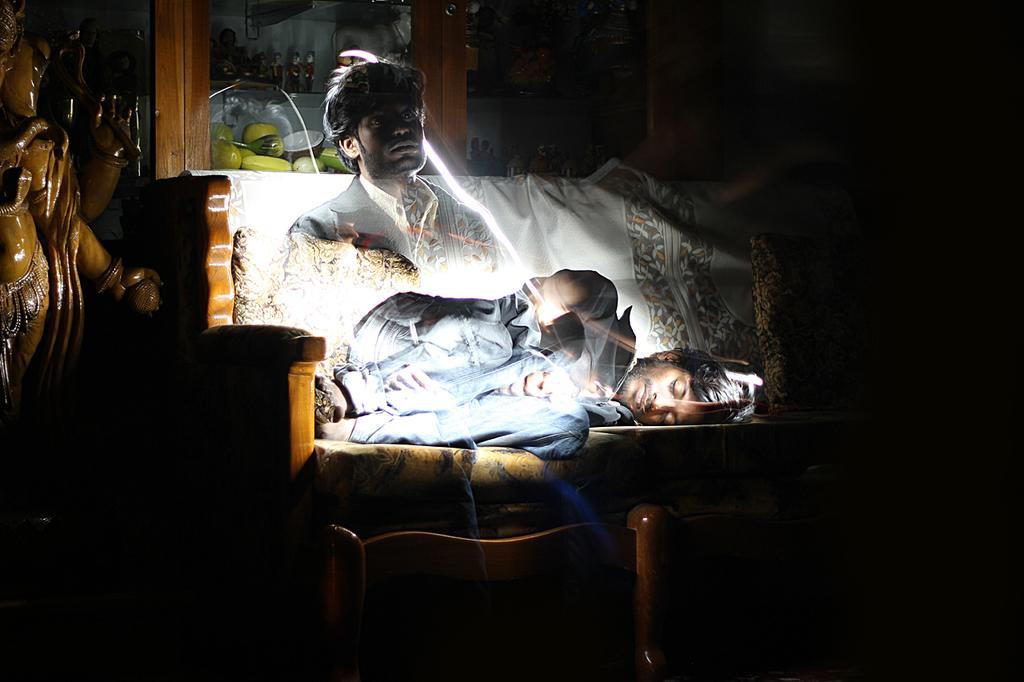Describe this image in one or two sentences. In the image on the sofa there's a man lying on it. And there is another man in transparent. On the left side of the image there is a statue. In the background there is a glass cupboard with few items in it. 